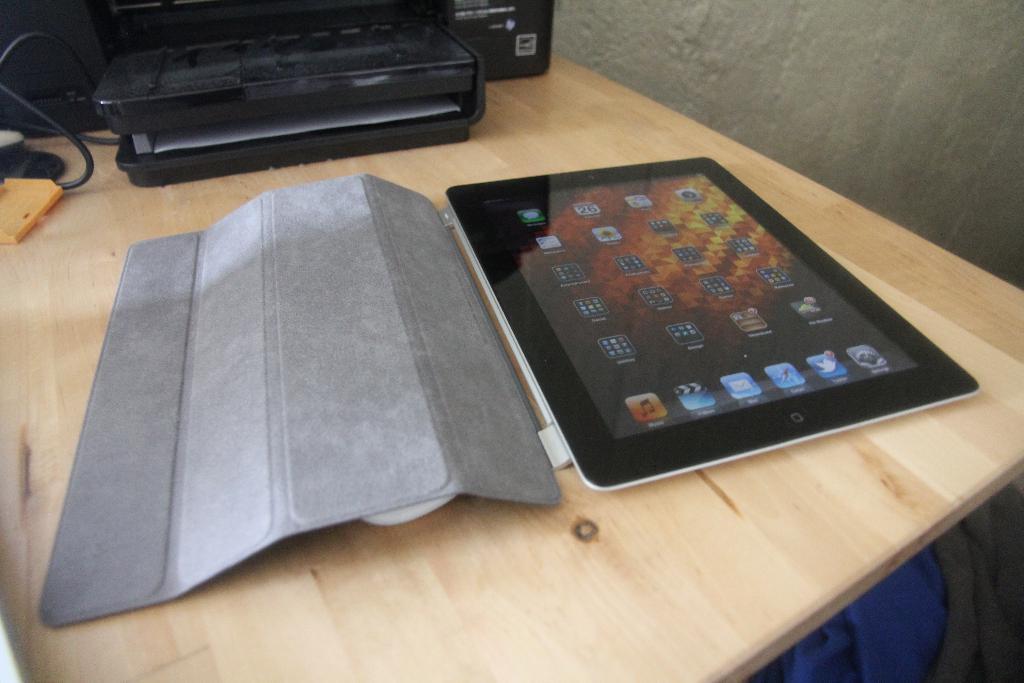Please provide a concise description of this image. This picture contains a tablet and a black color box are placed on the wooden table. Beside that, we see a wall in white color and at the bottom of the picture, we see a blue color sheet. 